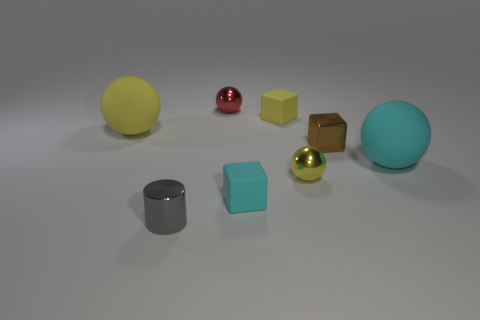Add 1 red shiny spheres. How many objects exist? 9 Subtract all blue spheres. Subtract all blue cubes. How many spheres are left? 4 Subtract all blocks. How many objects are left? 5 Add 6 gray metallic things. How many gray metallic things are left? 7 Add 2 big gray rubber spheres. How many big gray rubber spheres exist? 2 Subtract 0 yellow cylinders. How many objects are left? 8 Subtract all yellow blocks. Subtract all tiny red things. How many objects are left? 6 